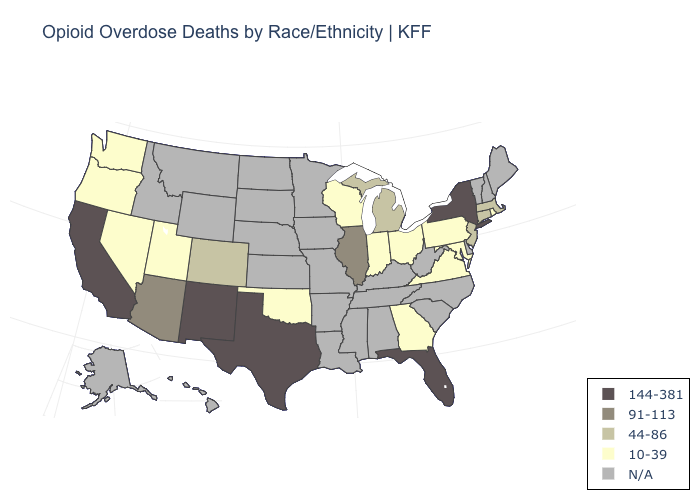Does Florida have the highest value in the USA?
Keep it brief. Yes. Is the legend a continuous bar?
Concise answer only. No. What is the lowest value in states that border Arkansas?
Write a very short answer. 10-39. Name the states that have a value in the range 91-113?
Short answer required. Arizona, Illinois. Does New Mexico have the highest value in the West?
Write a very short answer. Yes. How many symbols are there in the legend?
Short answer required. 5. Which states have the highest value in the USA?
Short answer required. California, Florida, New Mexico, New York, Texas. What is the highest value in the MidWest ?
Write a very short answer. 91-113. Name the states that have a value in the range 91-113?
Quick response, please. Arizona, Illinois. What is the value of Oklahoma?
Keep it brief. 10-39. Name the states that have a value in the range 91-113?
Concise answer only. Arizona, Illinois. 